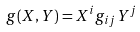Convert formula to latex. <formula><loc_0><loc_0><loc_500><loc_500>g ( X , Y ) = X ^ { i } g _ { i j } Y ^ { j }</formula> 